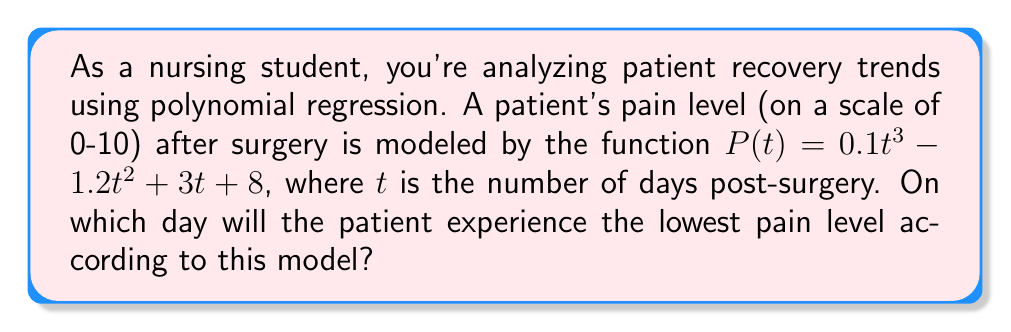Can you answer this question? To find the day with the lowest pain level, we need to follow these steps:

1) The lowest point of the function will occur at its minimum. To find this, we need to differentiate $P(t)$ and set it equal to zero.

2) The derivative of $P(t)$ is:
   $$P'(t) = 0.3t^2 - 2.4t + 3$$

3) Set $P'(t) = 0$:
   $$0.3t^2 - 2.4t + 3 = 0$$

4) This is a quadratic equation. We can solve it using the quadratic formula:
   $$t = \frac{-b \pm \sqrt{b^2 - 4ac}}{2a}$$
   where $a = 0.3$, $b = -2.4$, and $c = 3$

5) Substituting these values:
   $$t = \frac{2.4 \pm \sqrt{(-2.4)^2 - 4(0.3)(3)}}{2(0.3)}$$
   $$t = \frac{2.4 \pm \sqrt{5.76 - 3.6}}{0.6}$$
   $$t = \frac{2.4 \pm \sqrt{2.16}}{0.6}$$
   $$t = \frac{2.4 \pm 1.47}{0.6}$$

6) This gives us two solutions:
   $$t_1 = \frac{2.4 + 1.47}{0.6} \approx 6.45$$
   $$t_2 = \frac{2.4 - 1.47}{0.6} \approx 1.55$$

7) To determine which of these is the minimum (rather than the maximum), we can check the second derivative:
   $$P''(t) = 0.6t - 2.4$$

8) If we evaluate this at $t = 4$ (a point between our two solutions), we get:
   $$P''(4) = 0.6(4) - 2.4 = 0$$
   This is positive, indicating that the function is concave up, so the smaller value of $t$ (1.55) corresponds to the minimum.

9) Since we're dealing with days, we need to round to the nearest whole number.

Therefore, the pain level will be lowest on day 2 post-surgery.
Answer: 2 days 